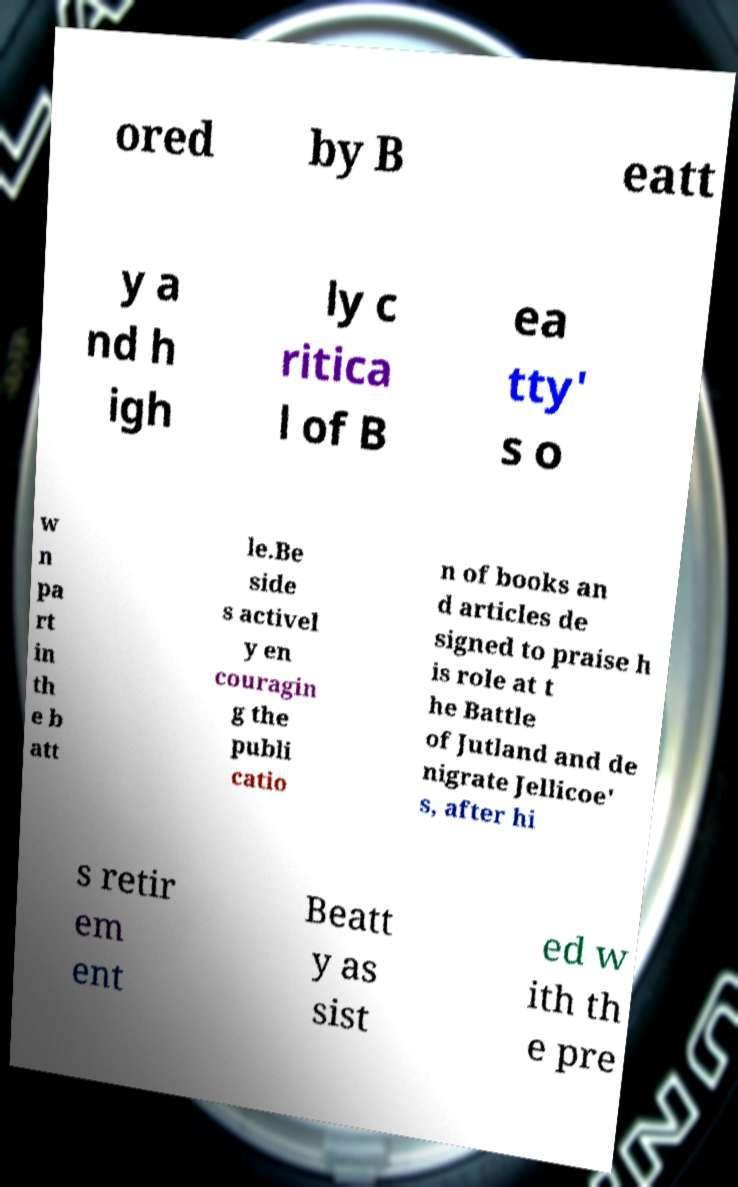Please read and relay the text visible in this image. What does it say? ored by B eatt y a nd h igh ly c ritica l of B ea tty' s o w n pa rt in th e b att le.Be side s activel y en couragin g the publi catio n of books an d articles de signed to praise h is role at t he Battle of Jutland and de nigrate Jellicoe' s, after hi s retir em ent Beatt y as sist ed w ith th e pre 